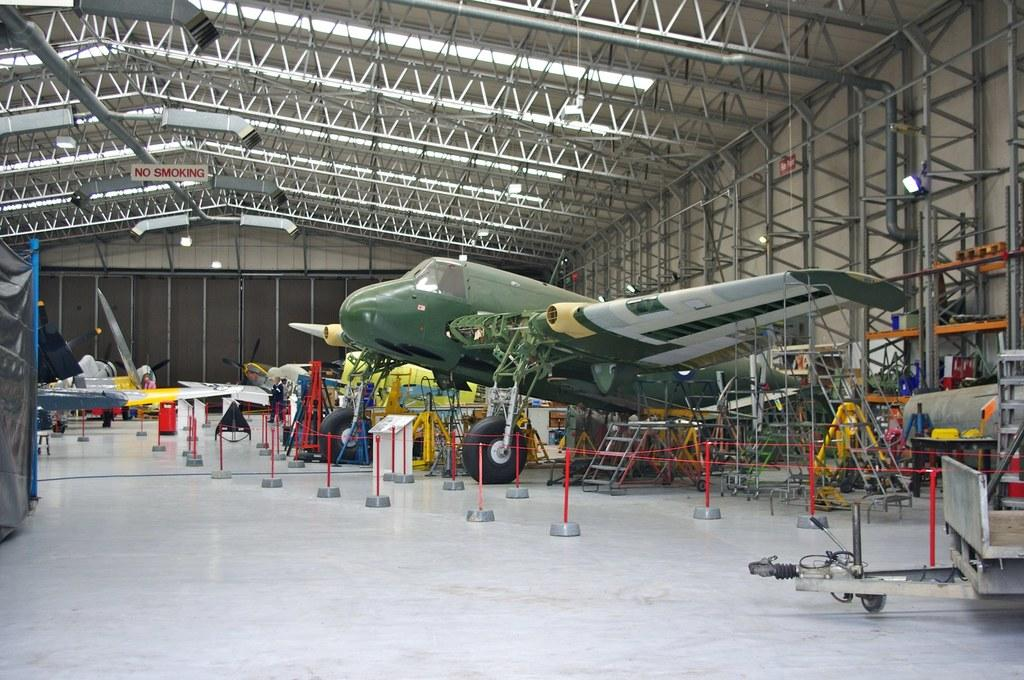Provide a one-sentence caption for the provided image. Small aircraft hangar which does not allow smoking. 